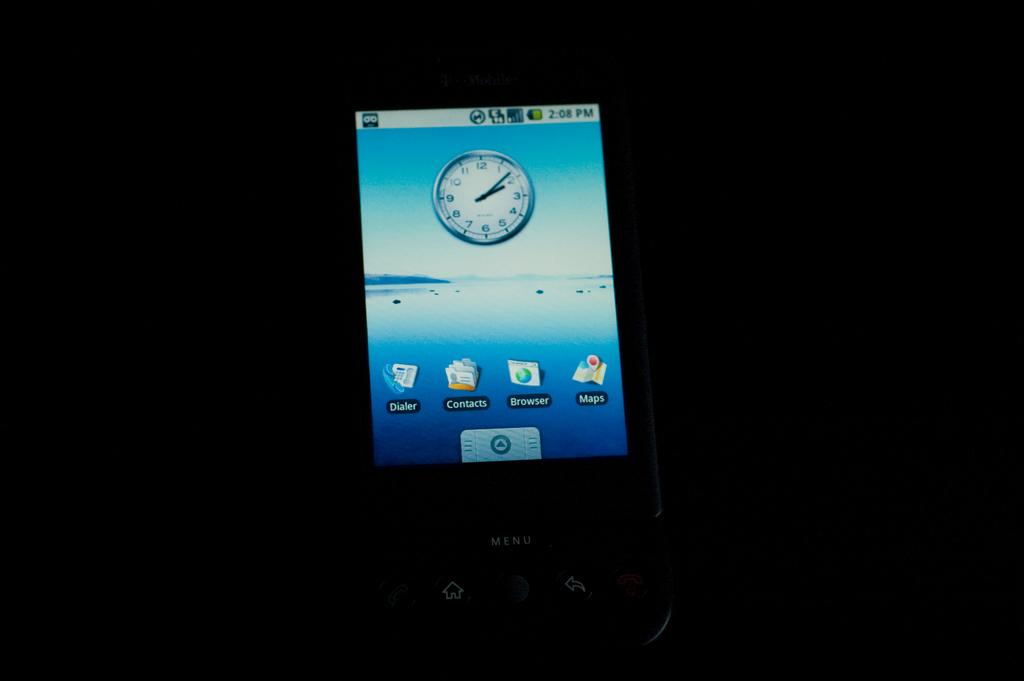<image>
Offer a succinct explanation of the picture presented. Phone screen which has an app called Dialer on it. 